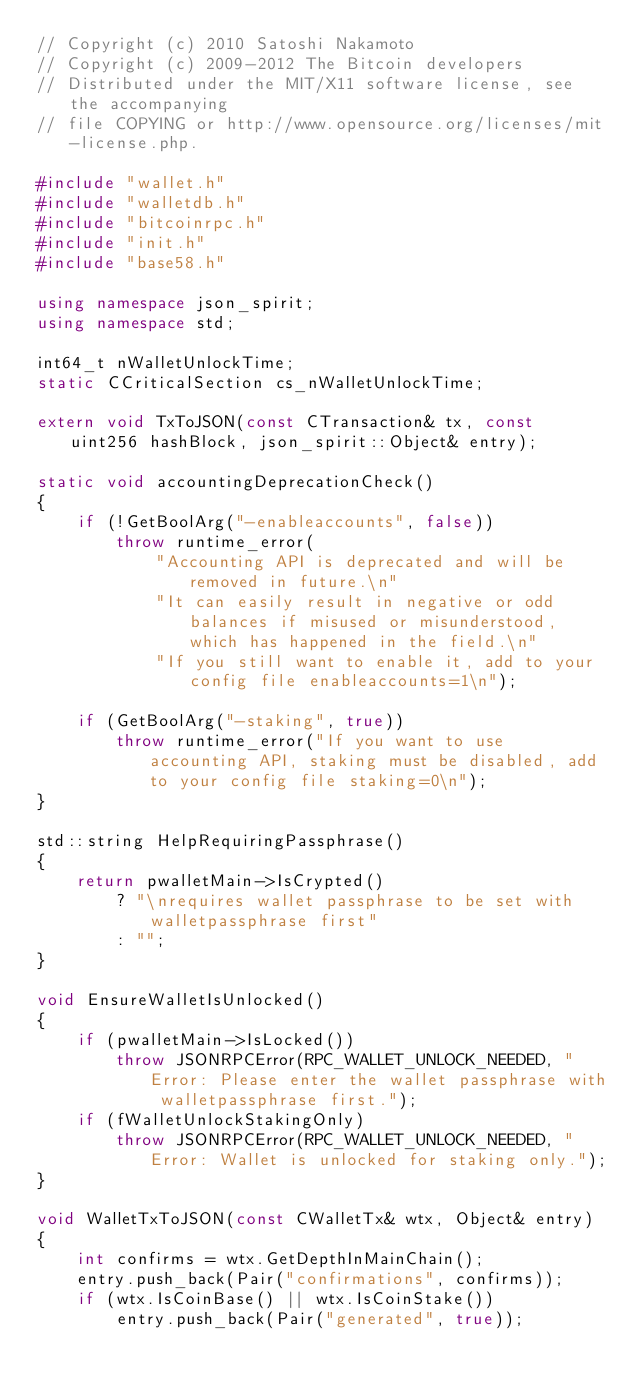<code> <loc_0><loc_0><loc_500><loc_500><_C++_>// Copyright (c) 2010 Satoshi Nakamoto
// Copyright (c) 2009-2012 The Bitcoin developers
// Distributed under the MIT/X11 software license, see the accompanying
// file COPYING or http://www.opensource.org/licenses/mit-license.php.

#include "wallet.h"
#include "walletdb.h"
#include "bitcoinrpc.h"
#include "init.h"
#include "base58.h"

using namespace json_spirit;
using namespace std;

int64_t nWalletUnlockTime;
static CCriticalSection cs_nWalletUnlockTime;

extern void TxToJSON(const CTransaction& tx, const uint256 hashBlock, json_spirit::Object& entry);

static void accountingDeprecationCheck()
{
    if (!GetBoolArg("-enableaccounts", false))
        throw runtime_error(
            "Accounting API is deprecated and will be removed in future.\n"
            "It can easily result in negative or odd balances if misused or misunderstood, which has happened in the field.\n"
            "If you still want to enable it, add to your config file enableaccounts=1\n");

    if (GetBoolArg("-staking", true))
        throw runtime_error("If you want to use accounting API, staking must be disabled, add to your config file staking=0\n");
}

std::string HelpRequiringPassphrase()
{
    return pwalletMain->IsCrypted()
        ? "\nrequires wallet passphrase to be set with walletpassphrase first"
        : "";
}

void EnsureWalletIsUnlocked()
{
    if (pwalletMain->IsLocked())
        throw JSONRPCError(RPC_WALLET_UNLOCK_NEEDED, "Error: Please enter the wallet passphrase with walletpassphrase first.");
    if (fWalletUnlockStakingOnly)
        throw JSONRPCError(RPC_WALLET_UNLOCK_NEEDED, "Error: Wallet is unlocked for staking only.");
}

void WalletTxToJSON(const CWalletTx& wtx, Object& entry)
{
    int confirms = wtx.GetDepthInMainChain();
    entry.push_back(Pair("confirmations", confirms));
    if (wtx.IsCoinBase() || wtx.IsCoinStake())
        entry.push_back(Pair("generated", true));</code> 